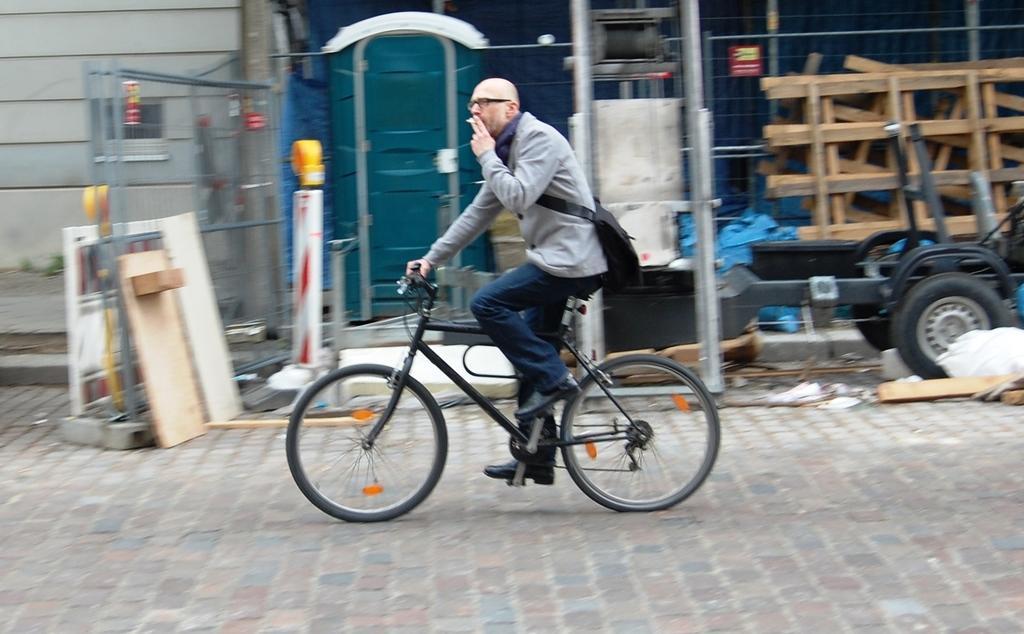Could you give a brief overview of what you see in this image? In this Image I see a man who is on the cycle and he is wearing a bag. In the background I see the building, a vehicle and few things over here. 